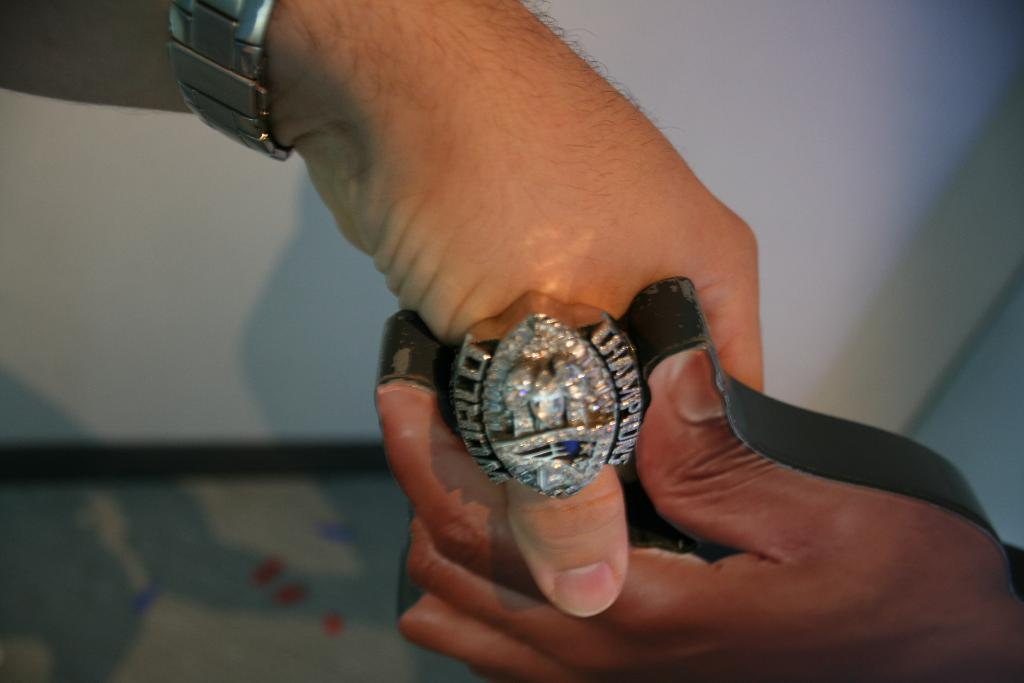<image>
Relay a brief, clear account of the picture shown. Person wearing a ring with the word CHAMPIONS on it. 